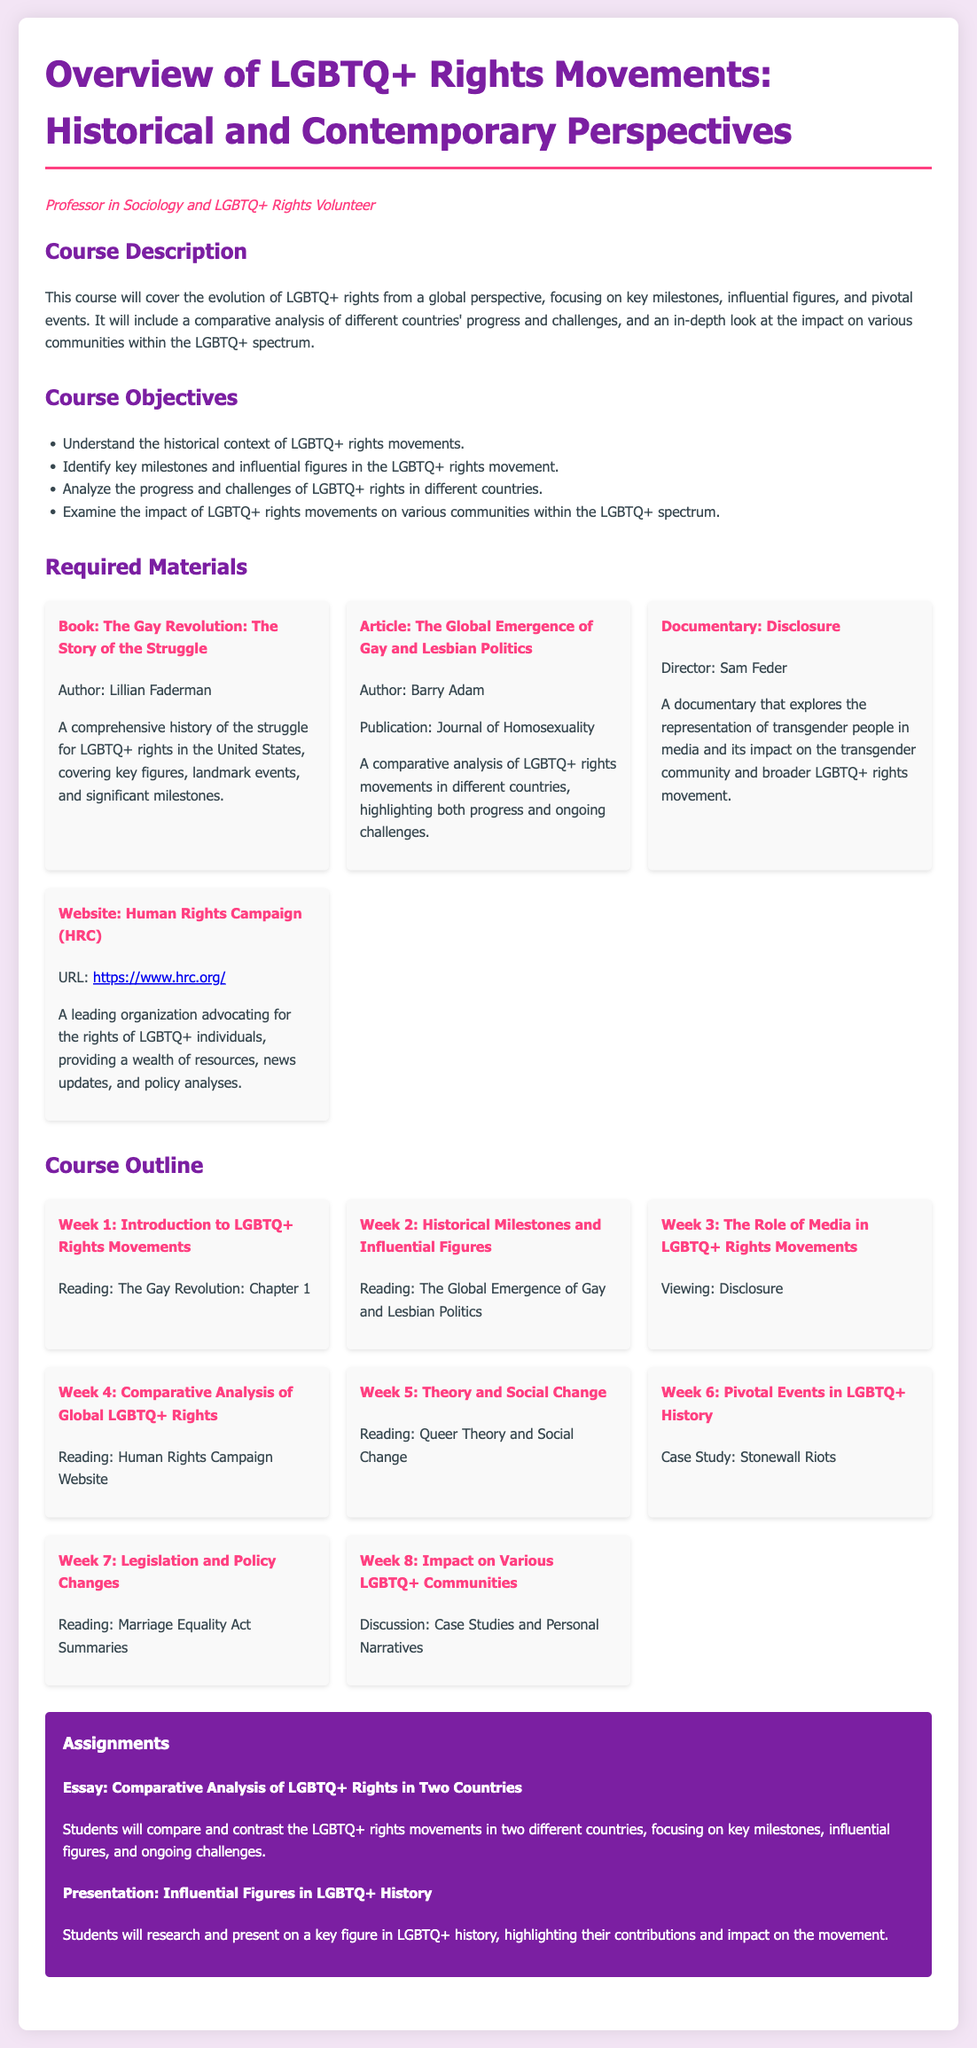What is the title of the syllabus? The title of the syllabus is stated at the beginning of the document.
Answer: Overview of LGBTQ+ Rights Movements: Historical and Contemporary Perspectives Who is the author of the book mentioned in Required Materials? The author's name is provided in the materials section for the specified book.
Answer: Lillian Faderman What documentary is listed as required viewing? The required documentary title is mentioned in the required materials section.
Answer: Disclosure How many weeks are outlined in the Course Outline? The number of weeks can be counted from the course outline section.
Answer: 8 What is the second week's topic in the Course Outline? The topic is specified for the second week in the course outline.
Answer: Historical Milestones and Influential Figures What type of assignment involves a comparative analysis? The assignment description states the type of analysis to be conducted.
Answer: Essay Which organization is the provided website associated with? The organization name is specified next to the URL in the materials section.
Answer: Human Rights Campaign What is one of the course objectives? Objectives are listed in the course objectives section.
Answer: Understand the historical context of LGBTQ+ rights movements 